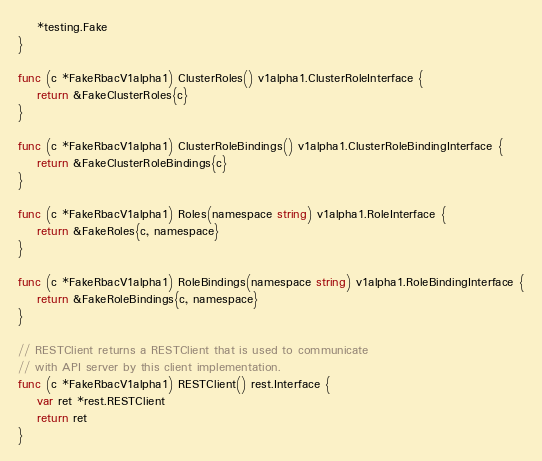<code> <loc_0><loc_0><loc_500><loc_500><_Go_>	*testing.Fake
}

func (c *FakeRbacV1alpha1) ClusterRoles() v1alpha1.ClusterRoleInterface {
	return &FakeClusterRoles{c}
}

func (c *FakeRbacV1alpha1) ClusterRoleBindings() v1alpha1.ClusterRoleBindingInterface {
	return &FakeClusterRoleBindings{c}
}

func (c *FakeRbacV1alpha1) Roles(namespace string) v1alpha1.RoleInterface {
	return &FakeRoles{c, namespace}
}

func (c *FakeRbacV1alpha1) RoleBindings(namespace string) v1alpha1.RoleBindingInterface {
	return &FakeRoleBindings{c, namespace}
}

// RESTClient returns a RESTClient that is used to communicate
// with API server by this client implementation.
func (c *FakeRbacV1alpha1) RESTClient() rest.Interface {
	var ret *rest.RESTClient
	return ret
}
</code> 